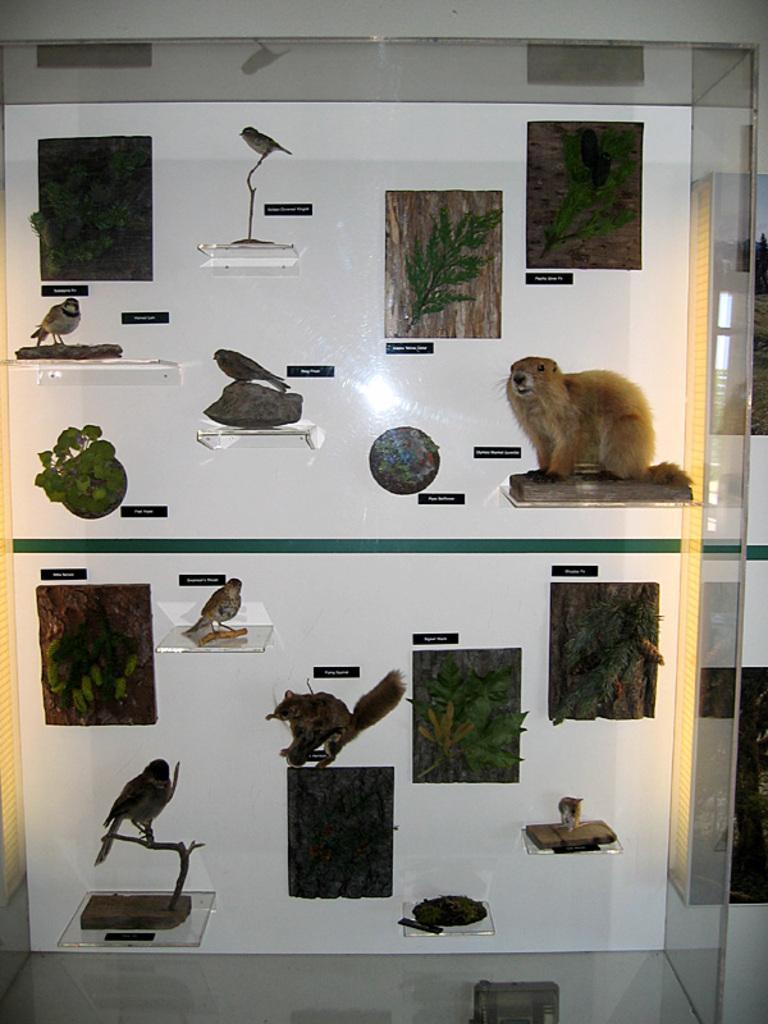Describe this image in one or two sentences. In this picture we can see posts on the wall and toys of animals and birds on shelves. 